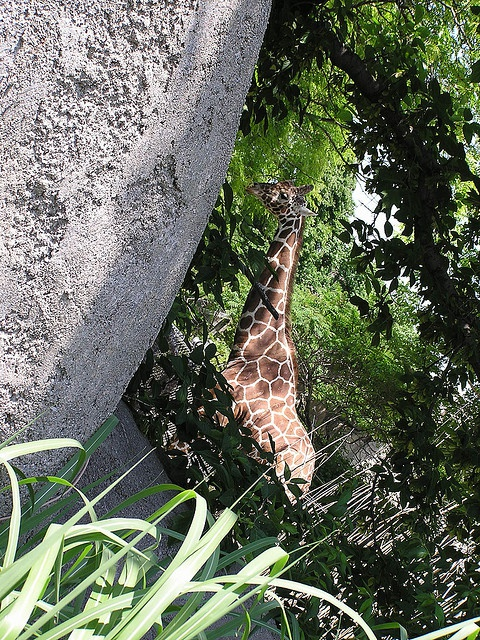Describe the objects in this image and their specific colors. I can see a giraffe in lightgray, black, white, gray, and tan tones in this image. 